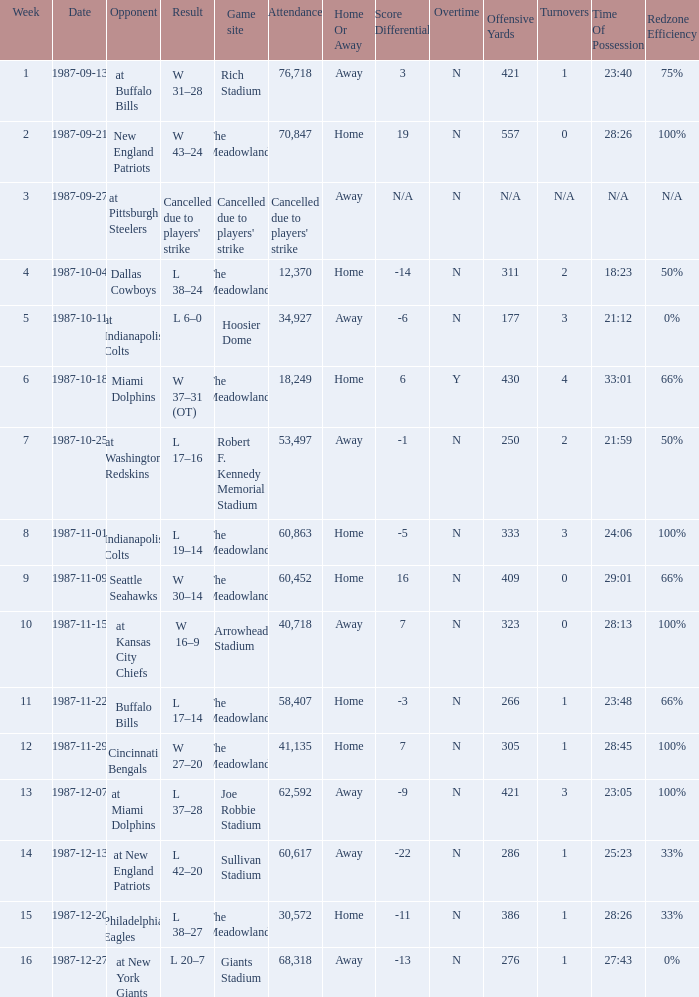Who did the Jets play in their pre-week 9 game at the Robert F. Kennedy memorial stadium? At washington redskins. 